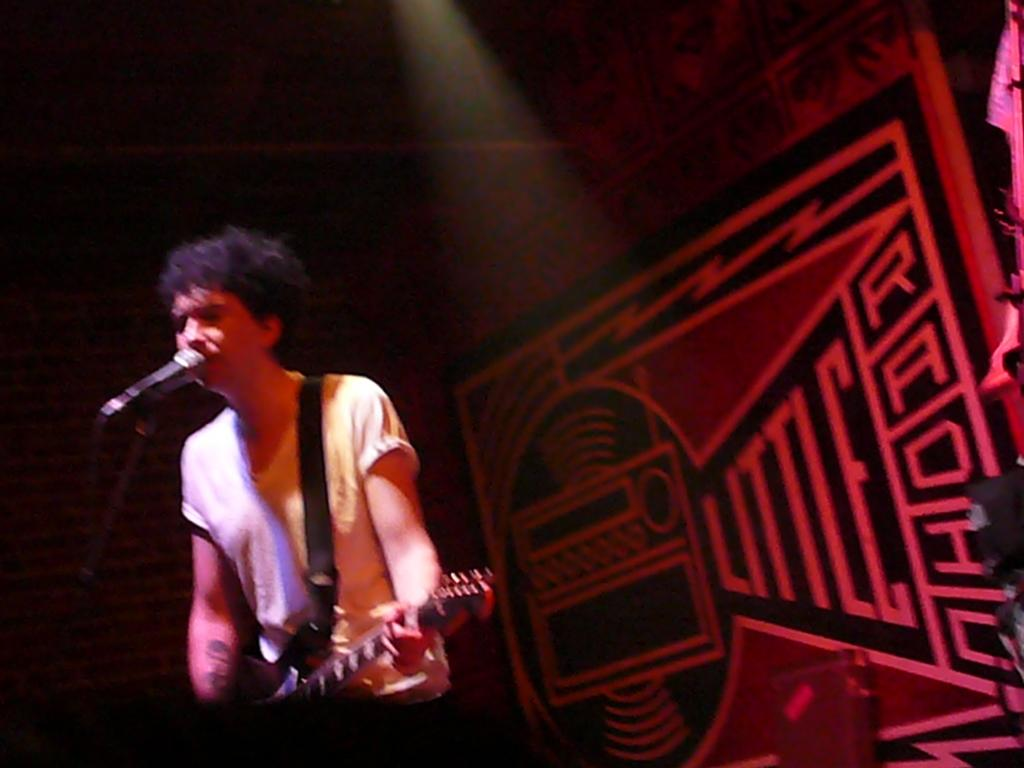What is the man in the image doing? The man is playing a guitar in the image. What object is present that is typically used for amplifying sound? There is a microphone, or "mike," in the image. What can be seen in the background of the image? There is a wall in the background of the image. What type of fowl can be seen flying in the image? There is no fowl present in the image; it features a man playing a guitar and a microphone. What type of ice is visible in the image? There is no ice present in the image. 